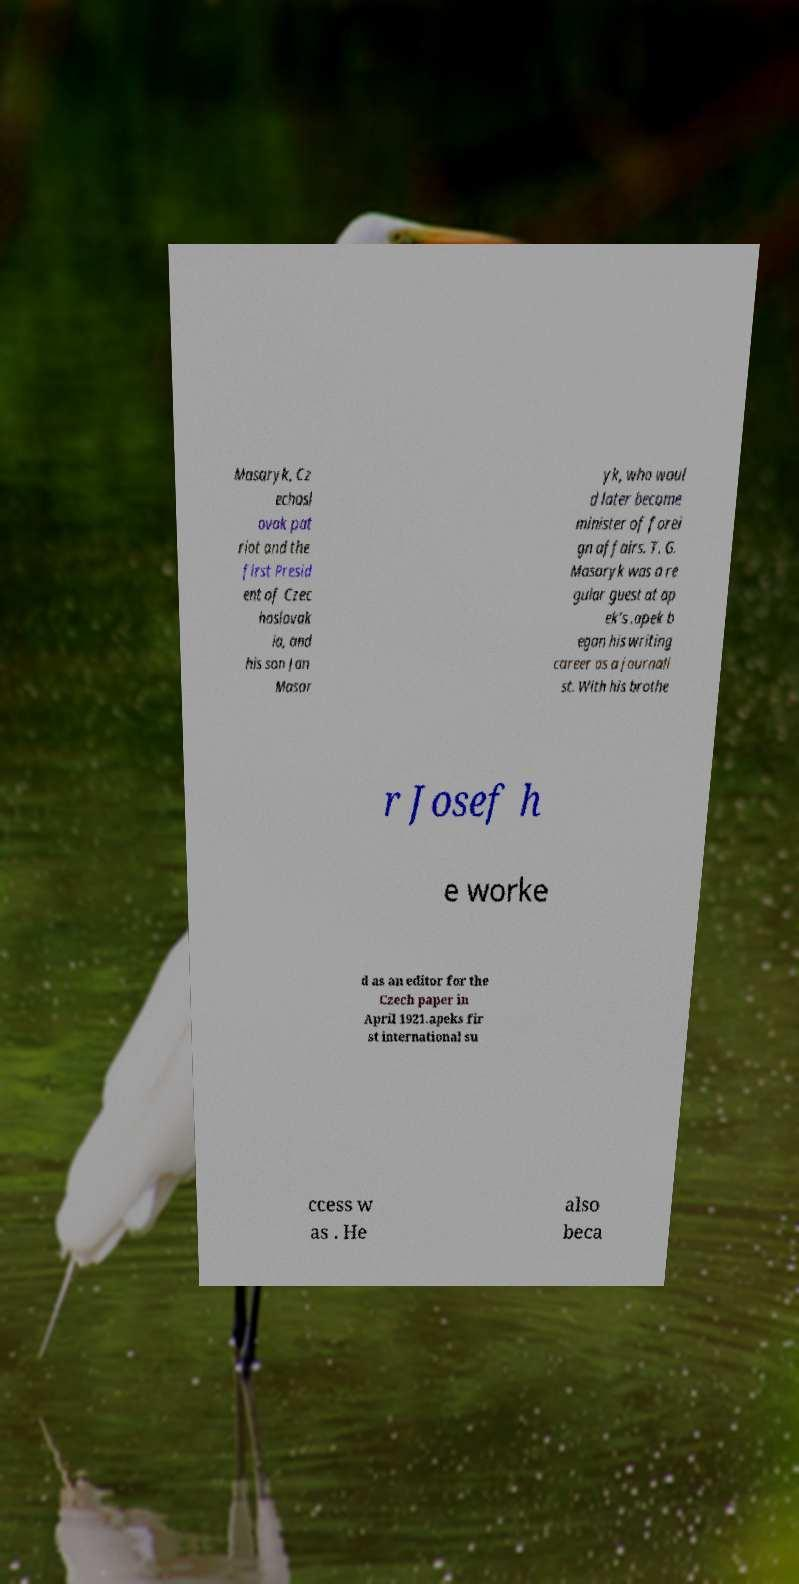Can you accurately transcribe the text from the provided image for me? Masaryk, Cz echosl ovak pat riot and the first Presid ent of Czec hoslovak ia, and his son Jan Masar yk, who woul d later become minister of forei gn affairs. T. G. Masaryk was a re gular guest at ap ek's .apek b egan his writing career as a journali st. With his brothe r Josef h e worke d as an editor for the Czech paper in April 1921.apeks fir st international su ccess w as . He also beca 